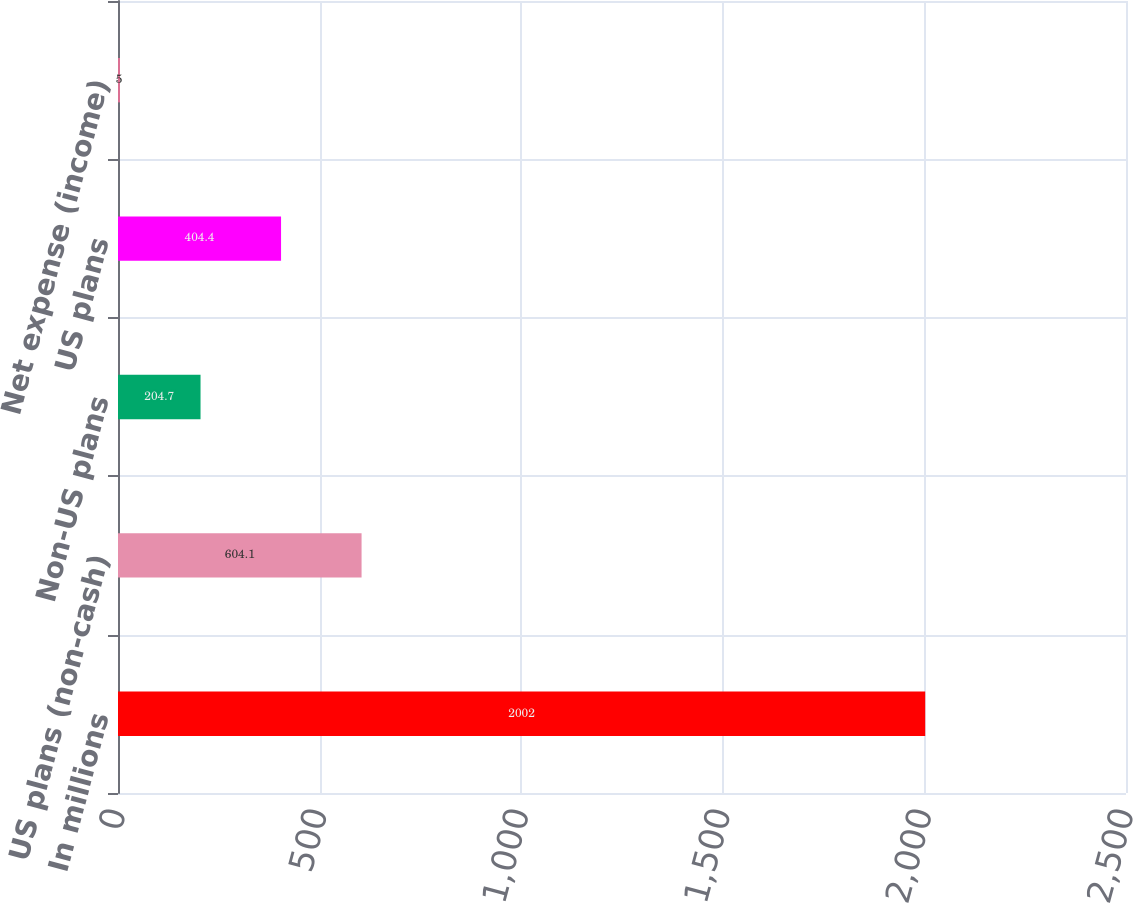Convert chart to OTSL. <chart><loc_0><loc_0><loc_500><loc_500><bar_chart><fcel>In millions<fcel>US plans (non-cash)<fcel>Non-US plans<fcel>US plans<fcel>Net expense (income)<nl><fcel>2002<fcel>604.1<fcel>204.7<fcel>404.4<fcel>5<nl></chart> 